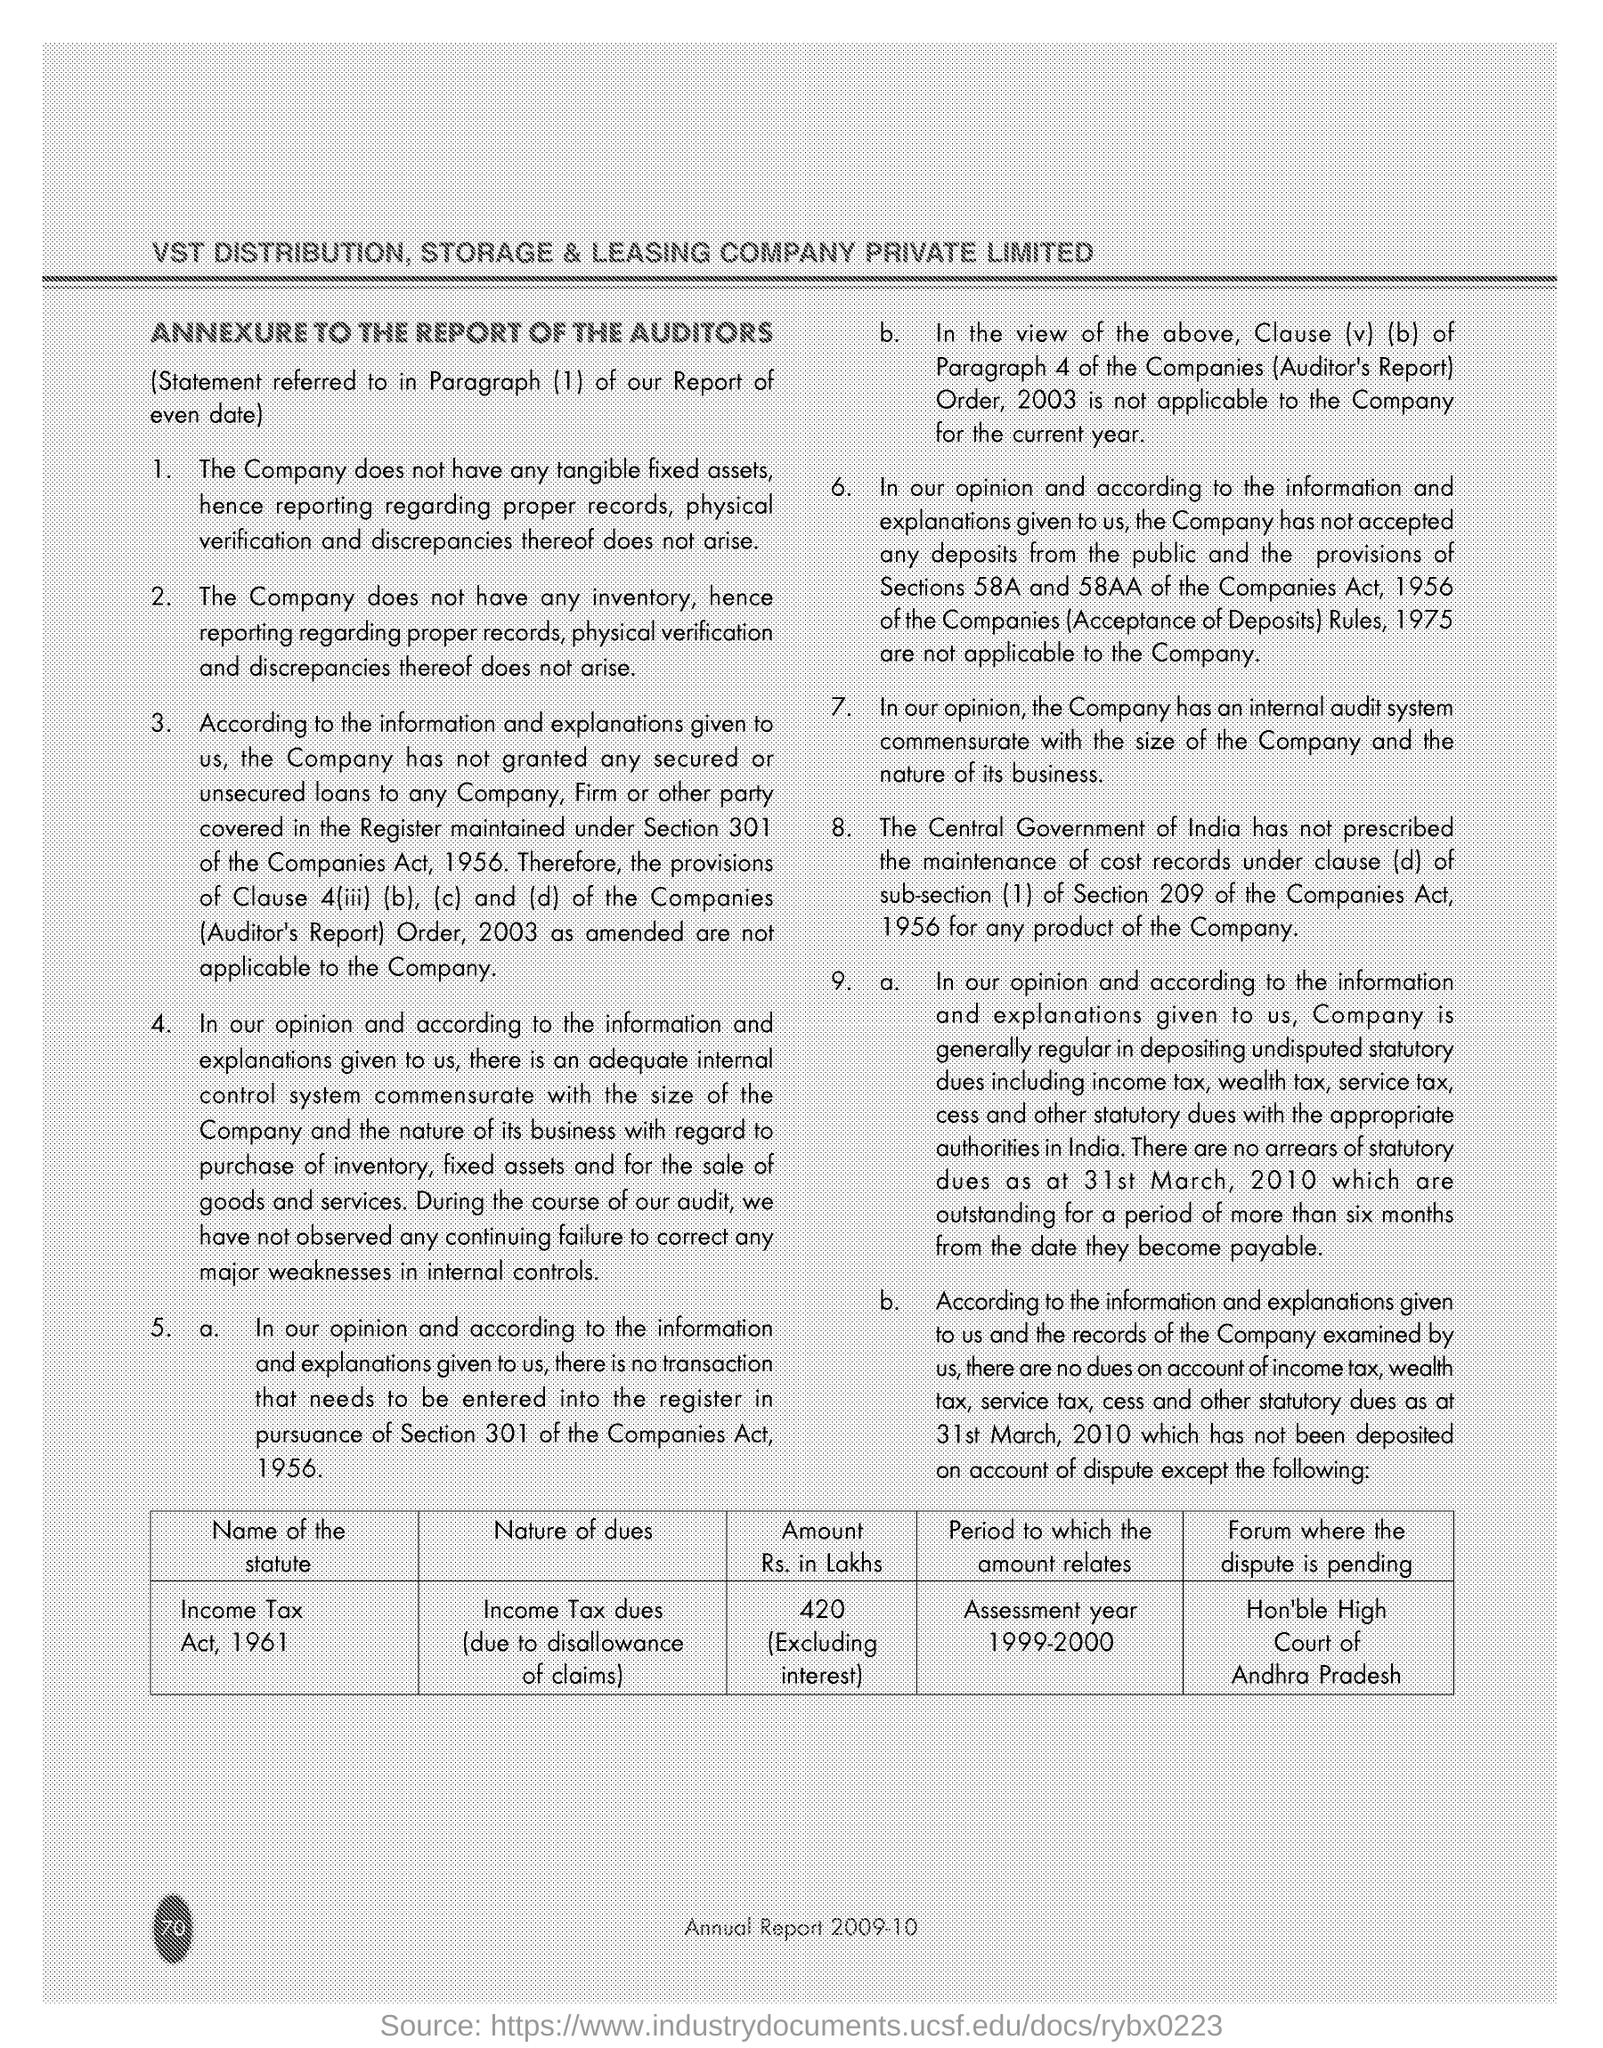According this page what is name of Statute?
Ensure brevity in your answer.  Income Tax Act, 1961. 